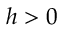Convert formula to latex. <formula><loc_0><loc_0><loc_500><loc_500>h > 0</formula> 